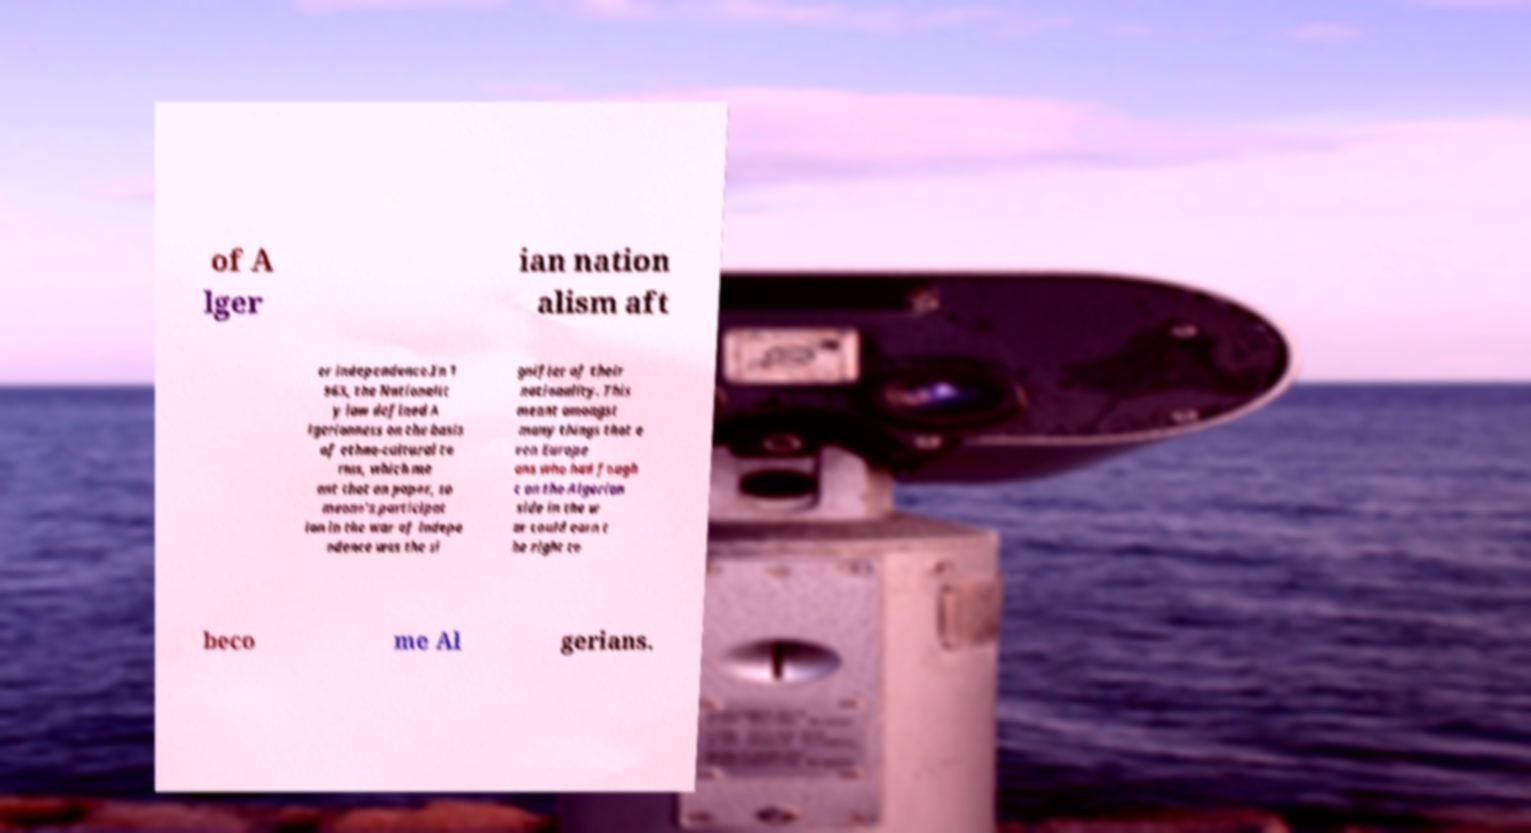I need the written content from this picture converted into text. Can you do that? of A lger ian nation alism aft er independence.In 1 963, the Nationalit y law defined A lgerianness on the basis of ethno-cultural te rms, which me ant that on paper, so meone's participat ion in the war of indepe ndence was the si gnifier of their nationality. This meant amongst many things that e ven Europe ans who had fough t on the Algerian side in the w ar could earn t he right to beco me Al gerians. 